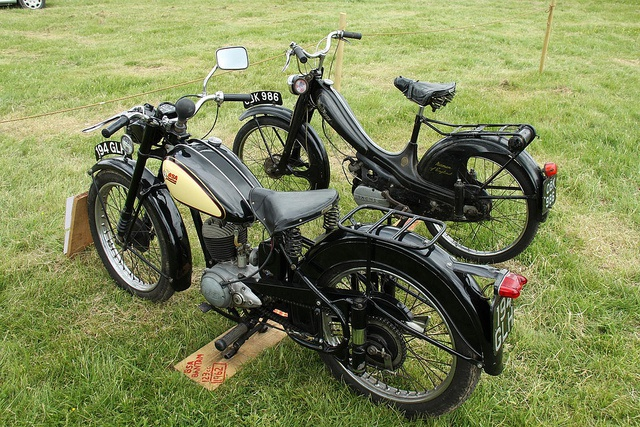Describe the objects in this image and their specific colors. I can see motorcycle in white, black, gray, darkgray, and olive tones and bicycle in white, black, gray, olive, and darkgray tones in this image. 